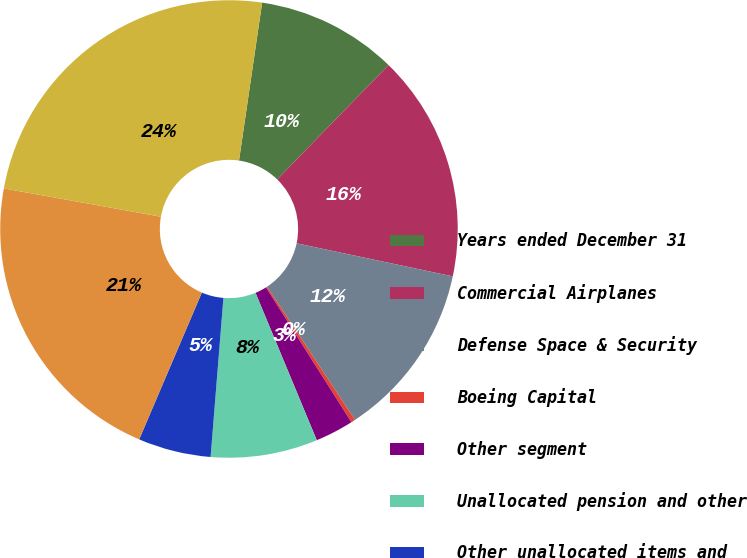Convert chart. <chart><loc_0><loc_0><loc_500><loc_500><pie_chart><fcel>Years ended December 31<fcel>Commercial Airplanes<fcel>Defense Space & Security<fcel>Boeing Capital<fcel>Other segment<fcel>Unallocated pension and other<fcel>Other unallocated items and<fcel>Earnings from operations<fcel>Core operating earnings<nl><fcel>9.97%<fcel>16.04%<fcel>12.39%<fcel>0.3%<fcel>2.72%<fcel>7.55%<fcel>5.14%<fcel>21.42%<fcel>24.48%<nl></chart> 